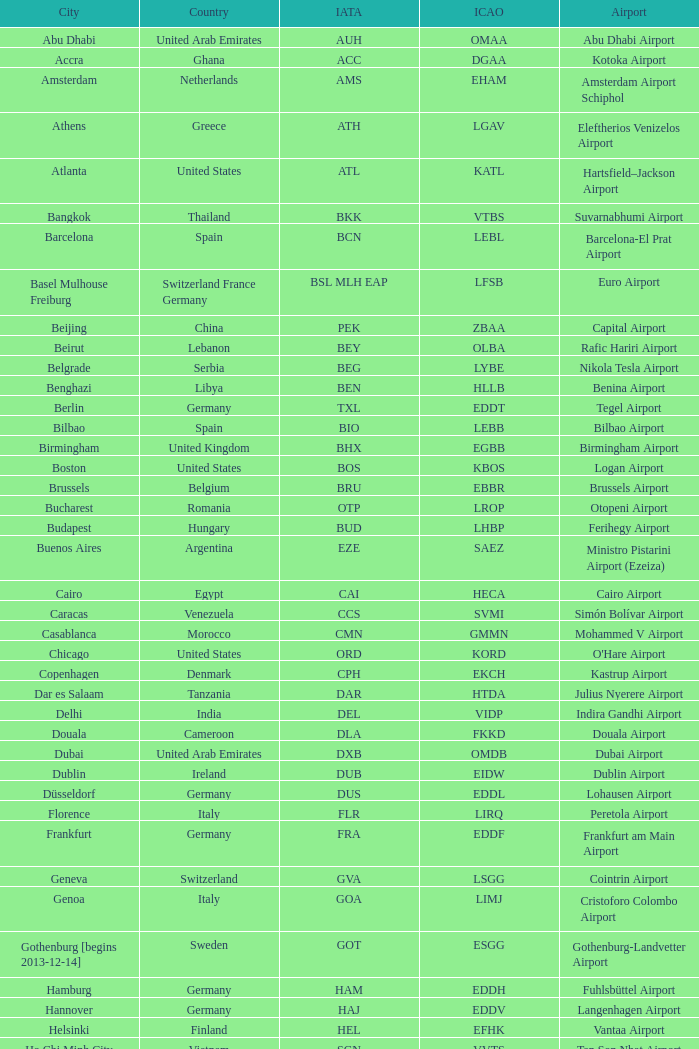What is the international civil aviation organization code for douala city? FKKD. 